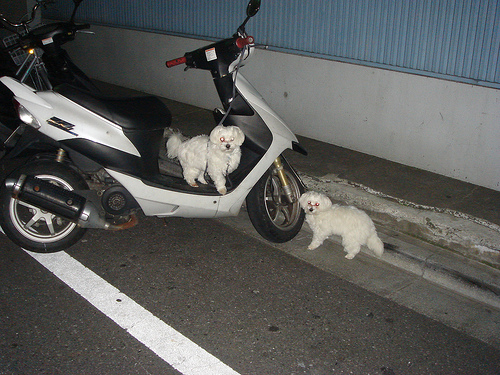Please provide a short description for this region: [0.37, 0.78, 0.47, 0.86]. The specified region shows a minor element of the background that appears as a white faded line along the pavement, aligning with the side of the vehicle. 